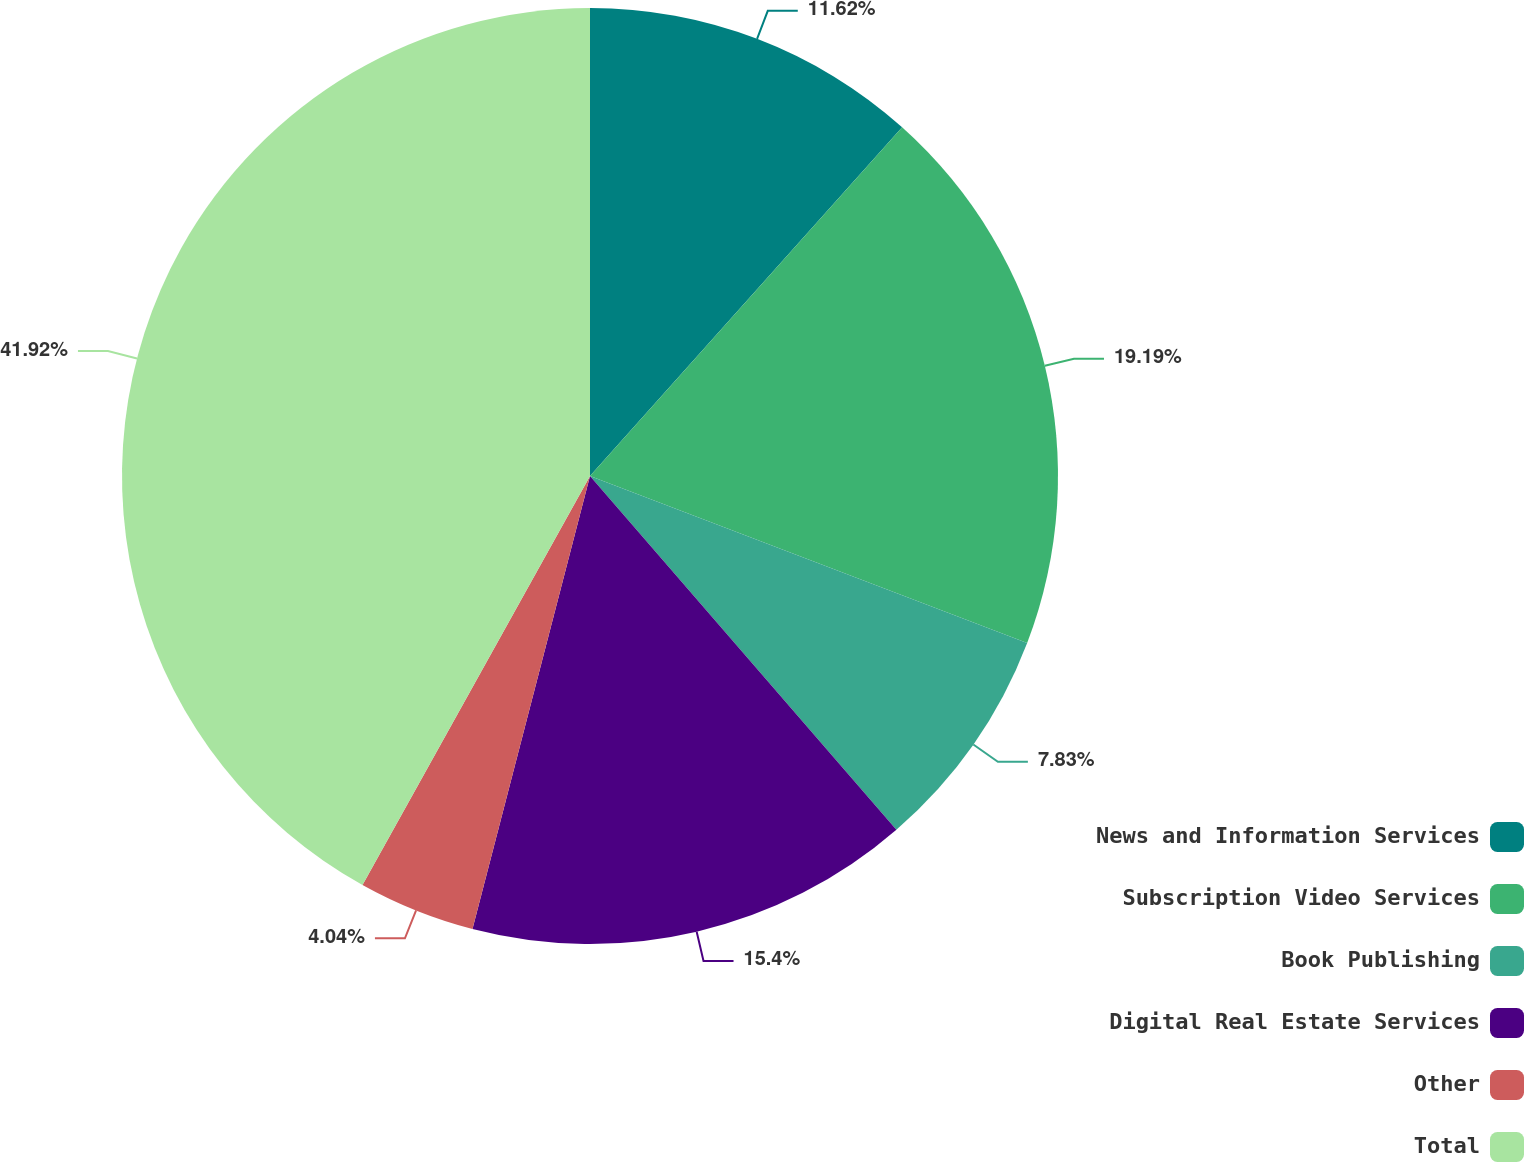Convert chart to OTSL. <chart><loc_0><loc_0><loc_500><loc_500><pie_chart><fcel>News and Information Services<fcel>Subscription Video Services<fcel>Book Publishing<fcel>Digital Real Estate Services<fcel>Other<fcel>Total<nl><fcel>11.62%<fcel>19.19%<fcel>7.83%<fcel>15.4%<fcel>4.04%<fcel>41.92%<nl></chart> 